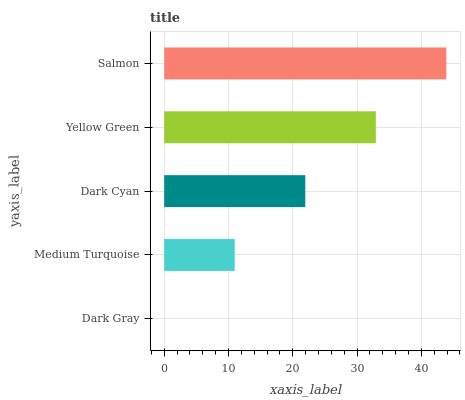Is Dark Gray the minimum?
Answer yes or no. Yes. Is Salmon the maximum?
Answer yes or no. Yes. Is Medium Turquoise the minimum?
Answer yes or no. No. Is Medium Turquoise the maximum?
Answer yes or no. No. Is Medium Turquoise greater than Dark Gray?
Answer yes or no. Yes. Is Dark Gray less than Medium Turquoise?
Answer yes or no. Yes. Is Dark Gray greater than Medium Turquoise?
Answer yes or no. No. Is Medium Turquoise less than Dark Gray?
Answer yes or no. No. Is Dark Cyan the high median?
Answer yes or no. Yes. Is Dark Cyan the low median?
Answer yes or no. Yes. Is Yellow Green the high median?
Answer yes or no. No. Is Yellow Green the low median?
Answer yes or no. No. 